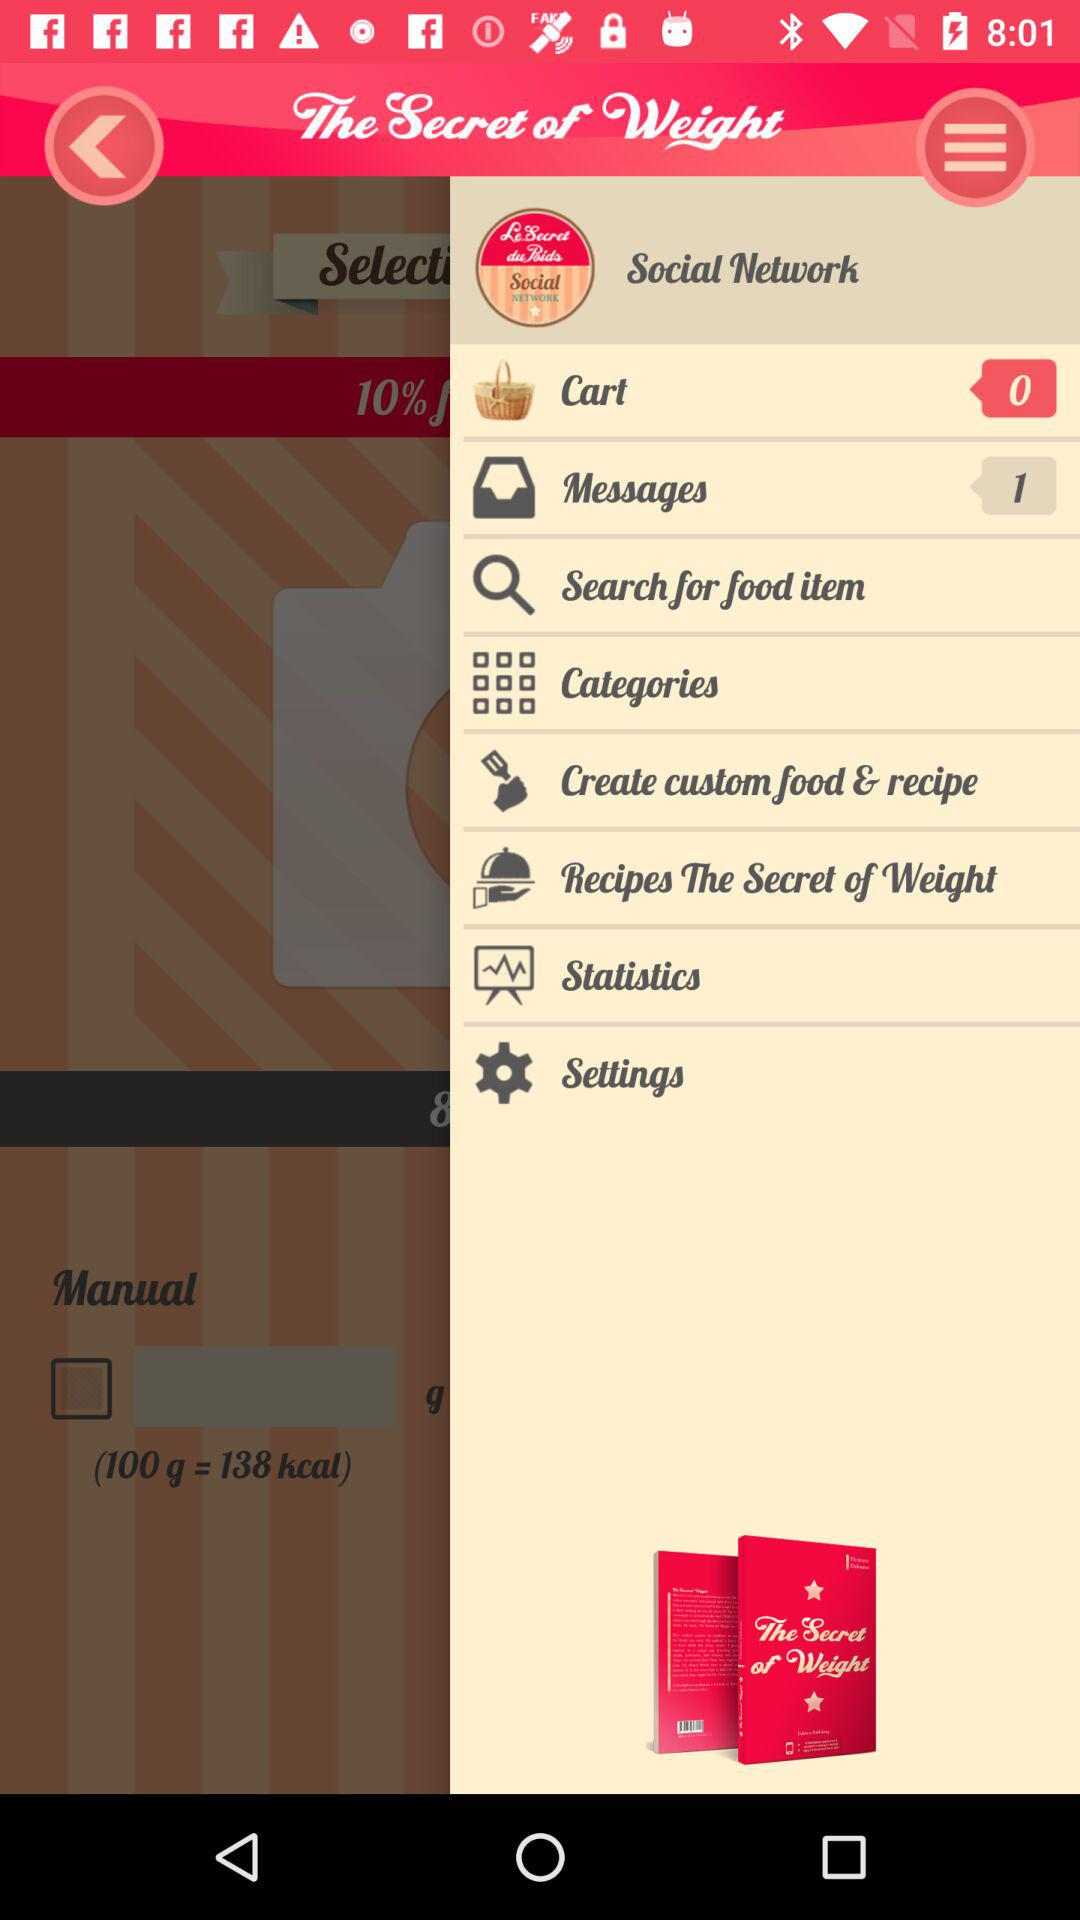How many items are there in the cart? There are 0 items. 